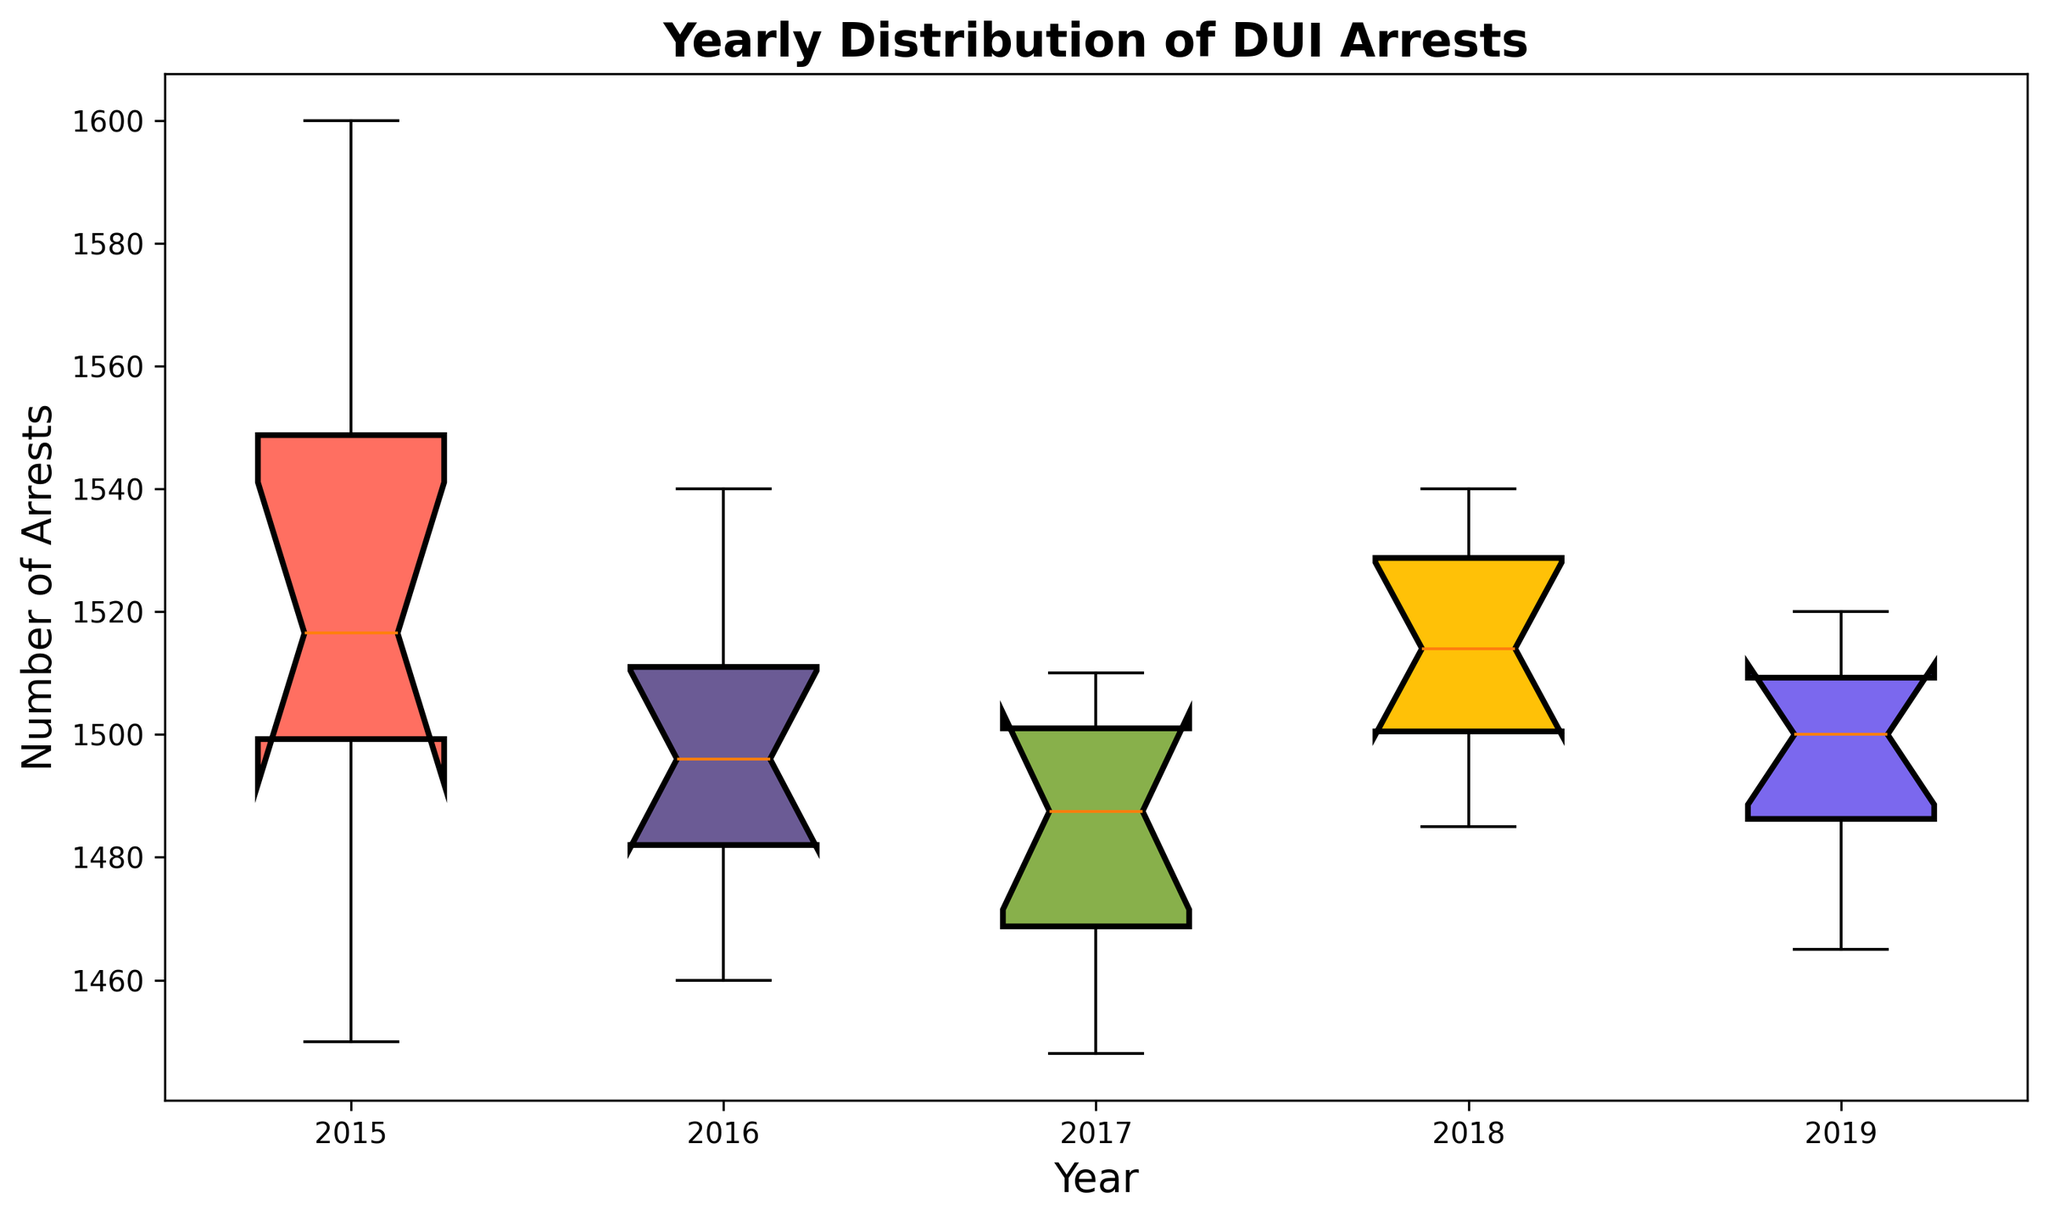What year has the highest median number of DUI arrests? To find the year with the highest median number of DUI arrests, look for the year with the middle line in the box (representing the median) positioned the highest on the y-axis.
Answer: 2018 Which year has the most outliers in DUI arrests? Outliers in a box plot are indicated by small circles or dots outside the whiskers. Count the number of outliers for each year to determine which year has the most.
Answer: 2015 Is the median number of DUI arrests higher in 2016 or 2017? Compare the median lines (middle lines inside the boxes) for the years 2016 and 2017. The year with the higher median line indicates a higher median number of arrests.
Answer: 2016 What is the range of the number of DUI arrests in 2019? The range is calculated by subtracting the smallest value (the lower whisker) from the largest value (the upper whisker).
Answer: 55 Which year shows the smallest interquartile range (IQR) of DUI arrests? The IQR is the height of the box in the box plot, representing the range between the first quartile (Q1) and the third quartile (Q3). The year with the shortest box has the smallest IQR.
Answer: 2016 Does 2017 have more variation in DUI arrests compared to 2018? Variation can be assessed by looking at the IQR, represented by the height of the box. Compare the heights of the boxes for 2017 and 2018. The taller box indicates more variation.
Answer: No How does the median number of DUI arrests in 2015 compare to 2019? Compare the median lines (middle lines inside the boxes) for the years 2015 and 2019. The year with the higher median line indicates a higher median number of arrests.
Answer: 2015 What can you infer about the distribution of DUI arrests in 2015 from the box plot? Examining the box plot for 2015, look at the median, the spread of the quartiles, and the number of outliers to infer about the distribution.
Answer: High median, wide distribution, many outliers Between which two consecutive years is the decrease in the median number of DUI arrests the greatest? Compare the median lines for consecutive years and identify the greatest drop between two years.
Answer: 2016 to 2017 Which year shows the most consistent number of DUI arrests? Consistency is shown by the smallest range and fewest outliers. The year with the shortest whiskers and the least number of outliers will be the most consistent.
Answer: 2016 